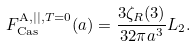Convert formula to latex. <formula><loc_0><loc_0><loc_500><loc_500>F _ { \text {Cas} } ^ { \text {A} , | | , T = 0 } ( a ) = \frac { 3 \zeta _ { R } ( 3 ) } { 3 2 \pi a ^ { 3 } } L _ { 2 } .</formula> 